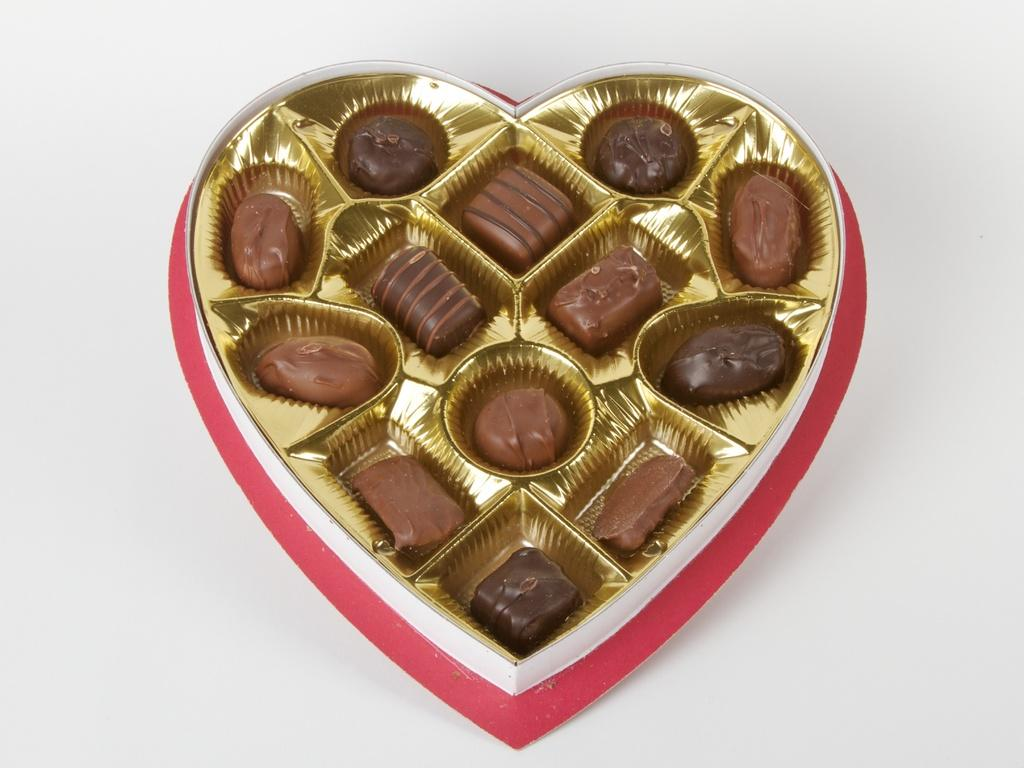What type of food items are present in the image? There are chocolates kept in a box in the image. How are the chocolates stored in the image? The chocolates are kept in a box in the image. What type of pen is being used to write on the chocolates in the image? There is no pen or writing on the chocolates in the image; it only shows chocolates kept in a box. How are the chocolates showing respect to each other in the image? The chocolates do not show respect to each other in the image, as they are inanimate objects. 